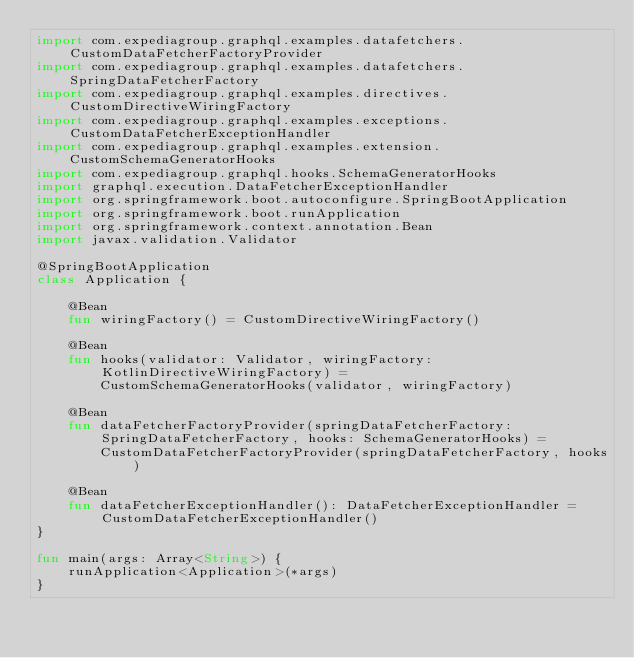<code> <loc_0><loc_0><loc_500><loc_500><_Kotlin_>import com.expediagroup.graphql.examples.datafetchers.CustomDataFetcherFactoryProvider
import com.expediagroup.graphql.examples.datafetchers.SpringDataFetcherFactory
import com.expediagroup.graphql.examples.directives.CustomDirectiveWiringFactory
import com.expediagroup.graphql.examples.exceptions.CustomDataFetcherExceptionHandler
import com.expediagroup.graphql.examples.extension.CustomSchemaGeneratorHooks
import com.expediagroup.graphql.hooks.SchemaGeneratorHooks
import graphql.execution.DataFetcherExceptionHandler
import org.springframework.boot.autoconfigure.SpringBootApplication
import org.springframework.boot.runApplication
import org.springframework.context.annotation.Bean
import javax.validation.Validator

@SpringBootApplication
class Application {

    @Bean
    fun wiringFactory() = CustomDirectiveWiringFactory()

    @Bean
    fun hooks(validator: Validator, wiringFactory: KotlinDirectiveWiringFactory) =
        CustomSchemaGeneratorHooks(validator, wiringFactory)

    @Bean
    fun dataFetcherFactoryProvider(springDataFetcherFactory: SpringDataFetcherFactory, hooks: SchemaGeneratorHooks) =
        CustomDataFetcherFactoryProvider(springDataFetcherFactory, hooks)

    @Bean
    fun dataFetcherExceptionHandler(): DataFetcherExceptionHandler = CustomDataFetcherExceptionHandler()
}

fun main(args: Array<String>) {
    runApplication<Application>(*args)
}
</code> 